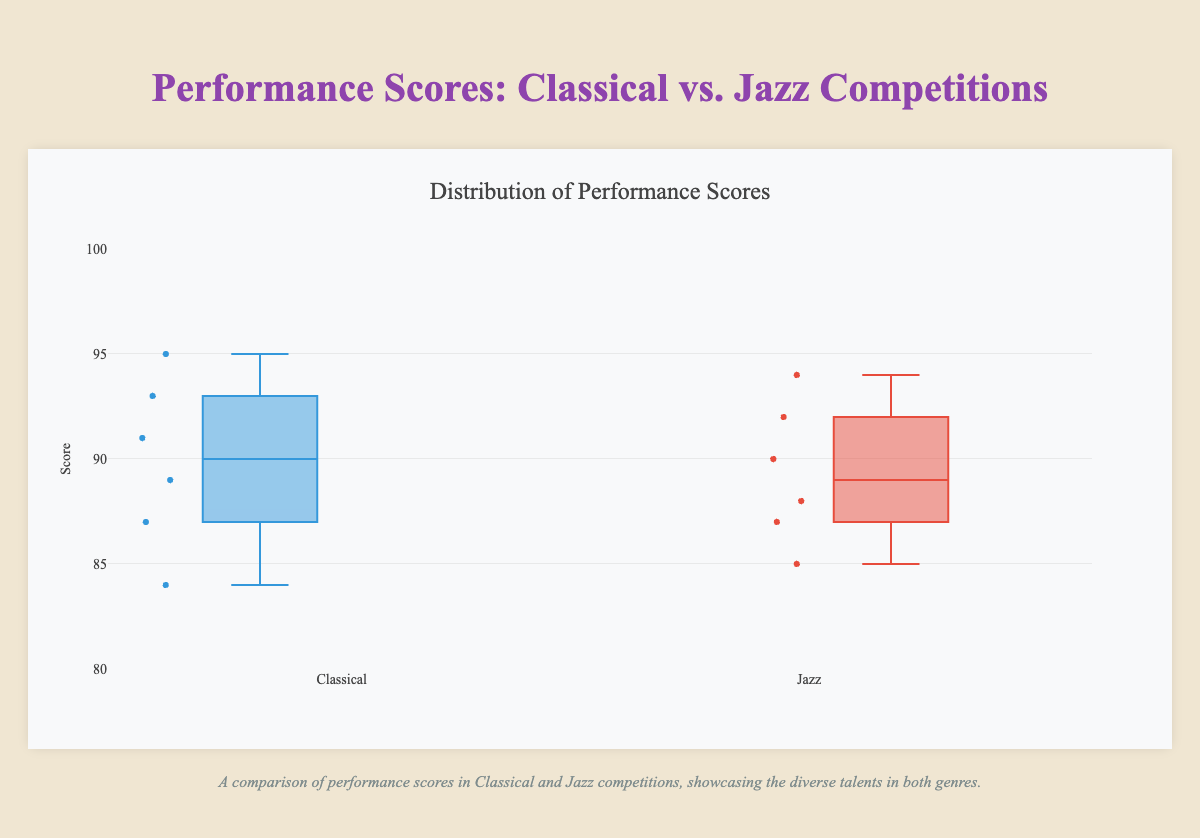What is the title of the plot? The title is prominently displayed at the top of the plot. It reads "Distribution of Performance Scores".
Answer: Distribution of Performance Scores What is the range of scores shown on the y-axis? The y-axis range is shown with specific tick marks from 80 to 100.
Answer: 80 to 100 How many performers are represented in the Classical Competitions group? Each box plot point represents an individual performer. There are six points shown in the Classical Competitions box plot.
Answer: 6 What is the median score for Jazz Competitions? The median is represented by the line inside the box in the box plot for Jazz Competitions. The line is at around 88.
Answer: 88 Which competition, Classical or Jazz, has a higher maximum score? The maximum score is represented by the top whisker of the box plot. The top whisker for Classical Competitions reaches up to 95, while for Jazz Competitions, it reaches 94.
Answer: Classical Competitions What is the interquartile range (IQR) for the Classical Competitions scores? The IQR is the distance between the first quartile (bottom of the box) and the third quartile (top of the box). For Classical Competitions, this difference is from around 87 to 93. Therefore, IQR = 93 - 87.
Answer: 6 Compare the spread of scores in Classical and Jazz Competitions. Which has a wider spread? The spread of scores can be gauged by the length of the whiskers. Classical’s whiskers span from 84 to 95, while Jazz’s whiskers span from 85 to 94. Since Classical’s spread is 11 (95-84) and Jazz’s spread is 9 (94-85), Classical has a wider spread.
Answer: Classical What is the lowest score in Jazz Competitions? The lowest score is represented by the bottom whisker of the Jazz Competitions box plot. The bottom whisker points to a score of 85.
Answer: 85 How does the median score of Classical Competitions compare to the median score of Jazz Competitions? The median for Classical Competitions is indicated by the middle line of the box and is approximately at 91. The median for Jazz is around 88. Thus, the Classical median is higher than the Jazz median.
Answer: Classical median is higher Identify an outlier in the Classical Competitions scores and explain its significance. Outliers are shown as individual points apart from whiskers. For Classical Competitions, suppose no points fall outside the range of the whiskers. Hence, there are no outliers present.
Answer: No outliers 